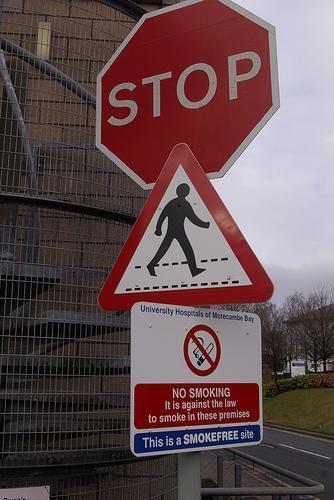How many sides does the bottom most sign have?
Give a very brief answer. 4. 